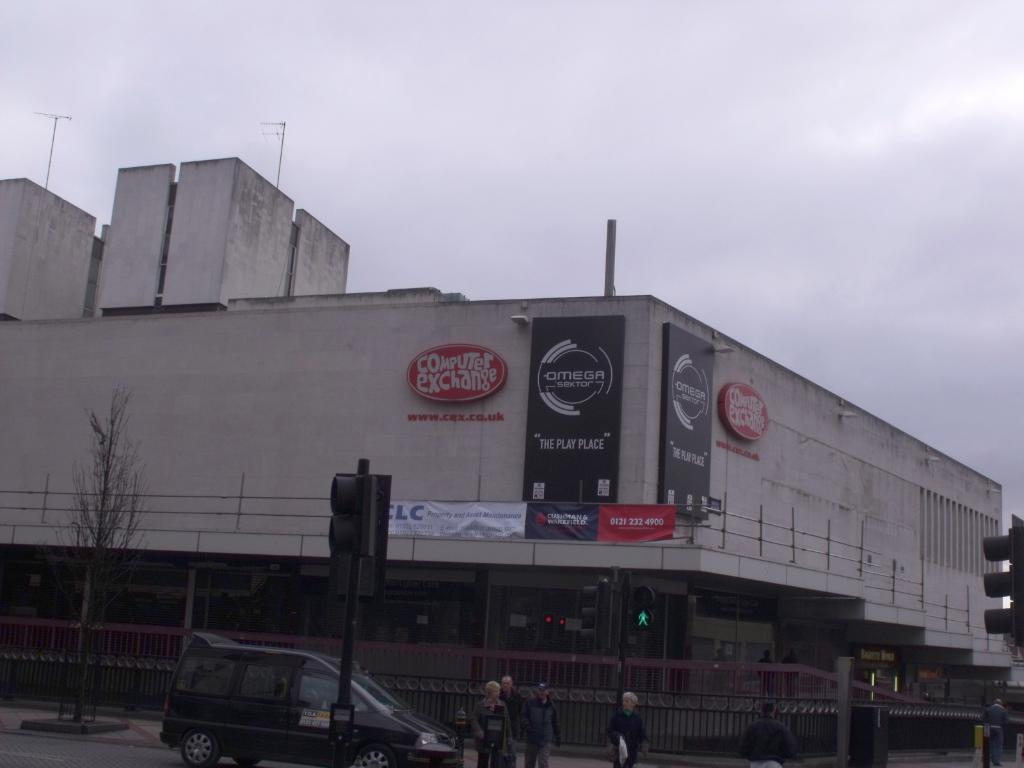What type of structure is visible in the image? There is a building in the image. What can be seen near the building? There are railings, banners, boards, poles, signal lights, a vehicle, and people visible in the image. Can you describe any natural elements in the image? There is a plant and a cloudy sky in the image. What else can be seen in the image? There are objects in the image. What is the tendency of the insurance company in the image? There is no mention of an insurance company in the image, so it is not possible to determine its tendency. 